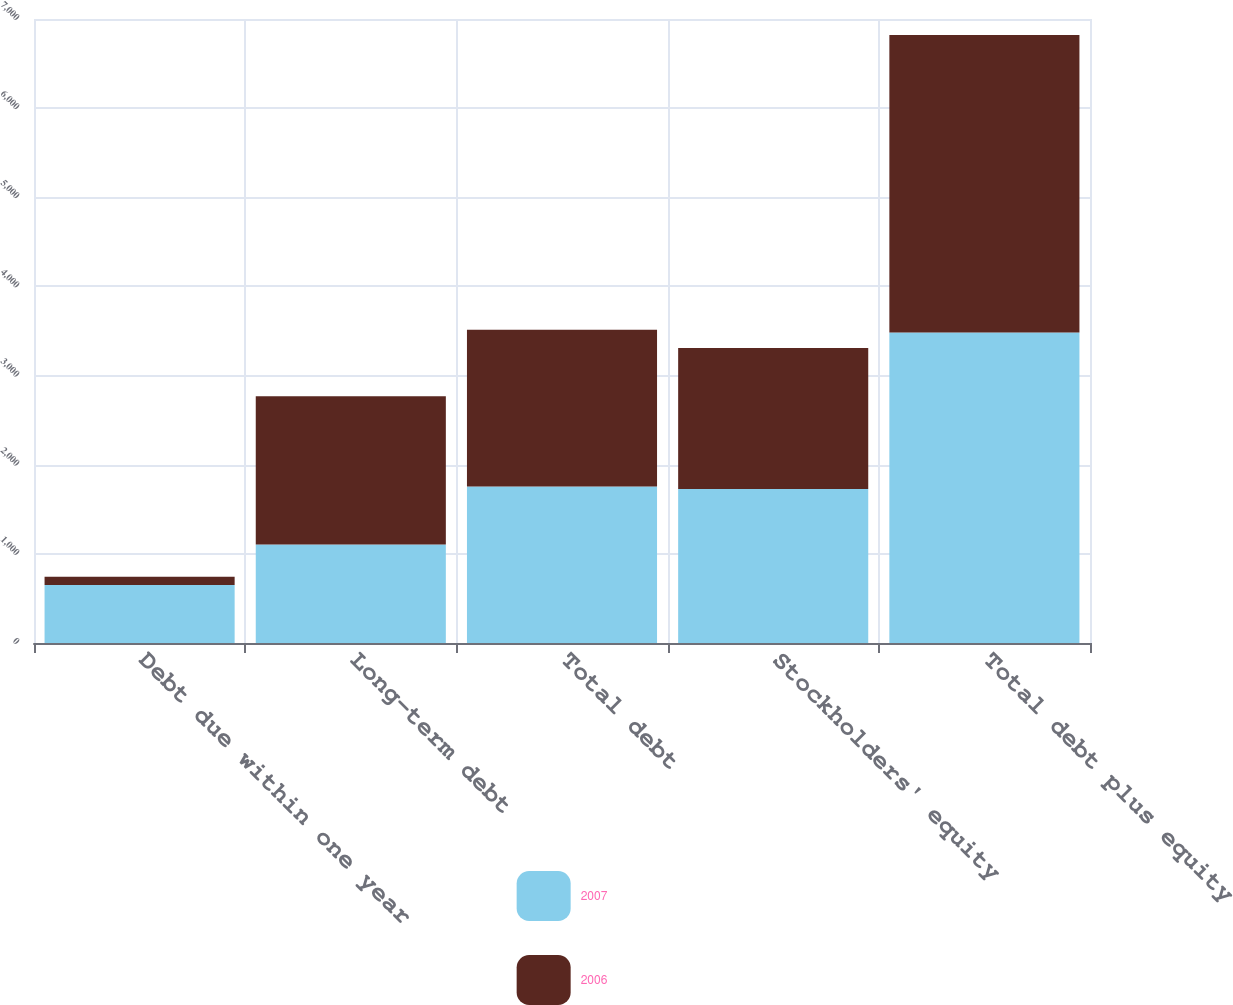Convert chart. <chart><loc_0><loc_0><loc_500><loc_500><stacked_bar_chart><ecel><fcel>Debt due within one year<fcel>Long-term debt<fcel>Total debt<fcel>Stockholders' equity<fcel>Total debt plus equity<nl><fcel>2007<fcel>650.9<fcel>1105<fcel>1755.9<fcel>1726.3<fcel>3482.2<nl><fcel>2006<fcel>92.8<fcel>1664.2<fcel>1757<fcel>1582.4<fcel>3339.4<nl></chart> 